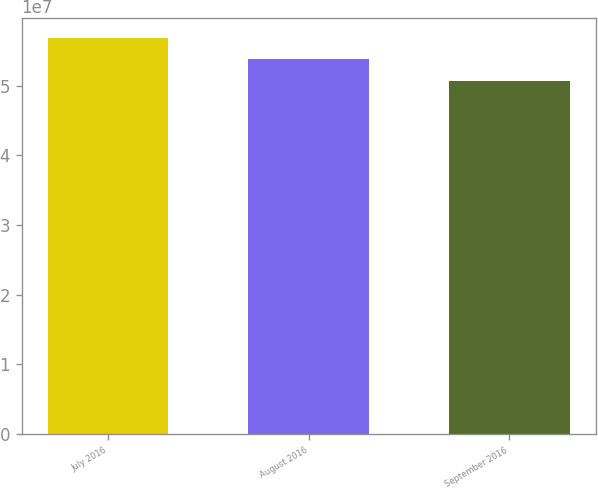<chart> <loc_0><loc_0><loc_500><loc_500><bar_chart><fcel>July 2016<fcel>August 2016<fcel>September 2016<nl><fcel>5.69033e+07<fcel>5.37655e+07<fcel>5.06849e+07<nl></chart> 